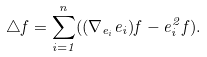<formula> <loc_0><loc_0><loc_500><loc_500>\triangle f = \sum _ { i = 1 } ^ { n } ( ( \nabla _ { e _ { i } } e _ { i } ) f - e _ { i } ^ { 2 } f ) .</formula> 